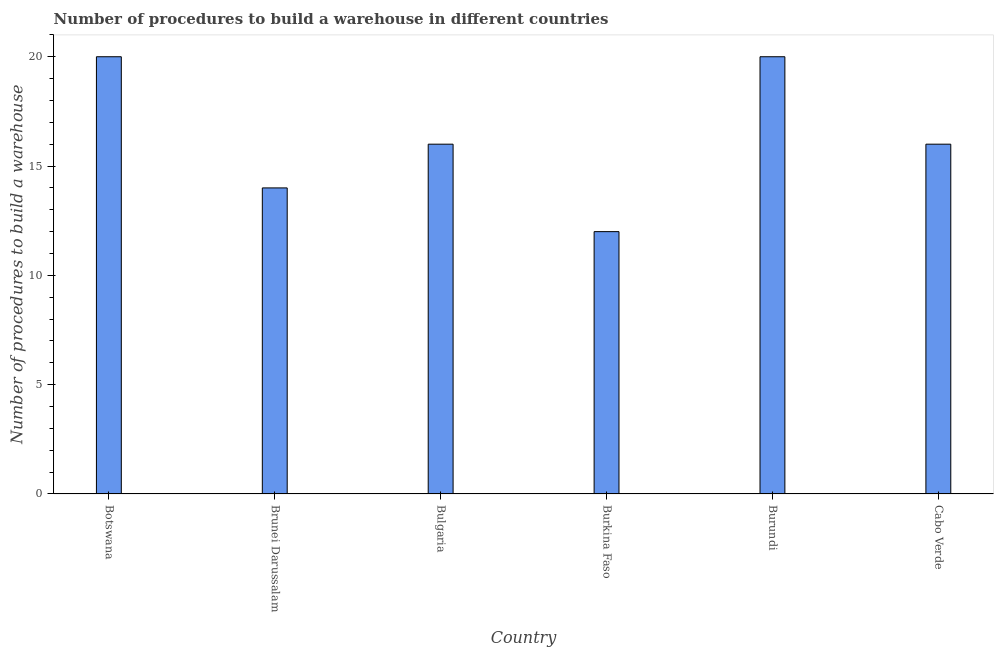Does the graph contain any zero values?
Offer a terse response. No. Does the graph contain grids?
Offer a terse response. No. What is the title of the graph?
Provide a short and direct response. Number of procedures to build a warehouse in different countries. What is the label or title of the X-axis?
Keep it short and to the point. Country. What is the label or title of the Y-axis?
Your answer should be compact. Number of procedures to build a warehouse. Across all countries, what is the maximum number of procedures to build a warehouse?
Provide a succinct answer. 20. Across all countries, what is the minimum number of procedures to build a warehouse?
Keep it short and to the point. 12. In which country was the number of procedures to build a warehouse maximum?
Offer a very short reply. Botswana. In which country was the number of procedures to build a warehouse minimum?
Provide a succinct answer. Burkina Faso. What is the sum of the number of procedures to build a warehouse?
Your response must be concise. 98. What is the average number of procedures to build a warehouse per country?
Ensure brevity in your answer.  16.33. In how many countries, is the number of procedures to build a warehouse greater than 1 ?
Make the answer very short. 6. What is the ratio of the number of procedures to build a warehouse in Bulgaria to that in Burkina Faso?
Offer a very short reply. 1.33. Is the difference between the number of procedures to build a warehouse in Burkina Faso and Burundi greater than the difference between any two countries?
Keep it short and to the point. Yes. In how many countries, is the number of procedures to build a warehouse greater than the average number of procedures to build a warehouse taken over all countries?
Your answer should be compact. 2. How many bars are there?
Offer a very short reply. 6. Are all the bars in the graph horizontal?
Offer a terse response. No. Are the values on the major ticks of Y-axis written in scientific E-notation?
Offer a very short reply. No. What is the Number of procedures to build a warehouse in Botswana?
Offer a terse response. 20. What is the Number of procedures to build a warehouse in Burundi?
Your response must be concise. 20. What is the difference between the Number of procedures to build a warehouse in Botswana and Brunei Darussalam?
Keep it short and to the point. 6. What is the difference between the Number of procedures to build a warehouse in Botswana and Bulgaria?
Your answer should be compact. 4. What is the difference between the Number of procedures to build a warehouse in Botswana and Burkina Faso?
Make the answer very short. 8. What is the difference between the Number of procedures to build a warehouse in Botswana and Burundi?
Provide a short and direct response. 0. What is the difference between the Number of procedures to build a warehouse in Brunei Darussalam and Bulgaria?
Your answer should be compact. -2. What is the difference between the Number of procedures to build a warehouse in Brunei Darussalam and Burundi?
Your response must be concise. -6. What is the difference between the Number of procedures to build a warehouse in Bulgaria and Burkina Faso?
Your answer should be compact. 4. What is the difference between the Number of procedures to build a warehouse in Bulgaria and Burundi?
Offer a very short reply. -4. What is the difference between the Number of procedures to build a warehouse in Burkina Faso and Burundi?
Provide a succinct answer. -8. What is the ratio of the Number of procedures to build a warehouse in Botswana to that in Brunei Darussalam?
Provide a succinct answer. 1.43. What is the ratio of the Number of procedures to build a warehouse in Botswana to that in Bulgaria?
Make the answer very short. 1.25. What is the ratio of the Number of procedures to build a warehouse in Botswana to that in Burkina Faso?
Your answer should be very brief. 1.67. What is the ratio of the Number of procedures to build a warehouse in Botswana to that in Cabo Verde?
Ensure brevity in your answer.  1.25. What is the ratio of the Number of procedures to build a warehouse in Brunei Darussalam to that in Burkina Faso?
Provide a short and direct response. 1.17. What is the ratio of the Number of procedures to build a warehouse in Bulgaria to that in Burkina Faso?
Offer a very short reply. 1.33. What is the ratio of the Number of procedures to build a warehouse in Burkina Faso to that in Burundi?
Make the answer very short. 0.6. What is the ratio of the Number of procedures to build a warehouse in Burkina Faso to that in Cabo Verde?
Offer a terse response. 0.75. 